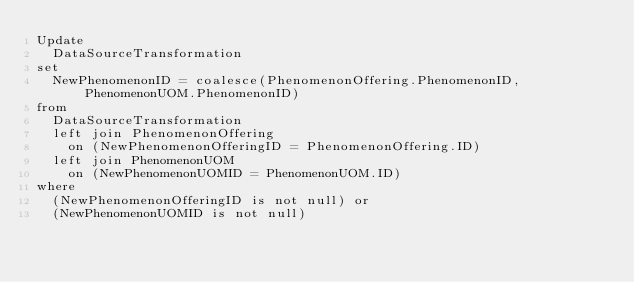<code> <loc_0><loc_0><loc_500><loc_500><_SQL_>Update
  DataSourceTransformation
set
  NewPhenomenonID = coalesce(PhenomenonOffering.PhenomenonID, PhenomenonUOM.PhenomenonID)
from
  DataSourceTransformation
  left join PhenomenonOffering
    on (NewPhenomenonOfferingID = PhenomenonOffering.ID)
  left join PhenomenonUOM
    on (NewPhenomenonUOMID = PhenomenonUOM.ID)
where
  (NewPhenomenonOfferingID is not null) or
  (NewPhenomenonUOMID is not null)</code> 